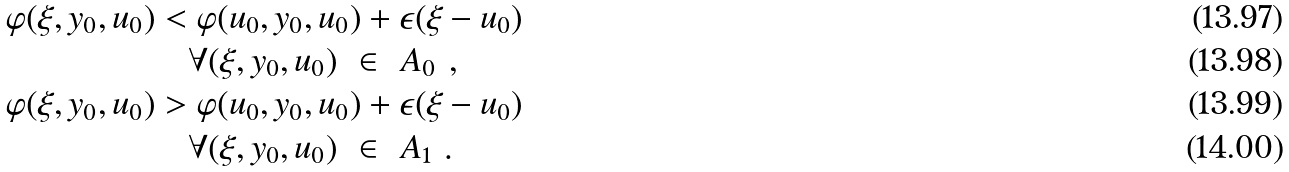<formula> <loc_0><loc_0><loc_500><loc_500>\varphi ( \xi , y _ { 0 } , u _ { 0 } ) & < \varphi ( u _ { 0 } , y _ { 0 } , u _ { 0 } ) + \epsilon ( \xi - u _ { 0 } ) \ \\ & \quad \forall ( \xi , y _ { 0 } , u _ { 0 } ) \ \in \ A _ { 0 } \ , \\ \varphi ( \xi , y _ { 0 } , u _ { 0 } ) & > \varphi ( u _ { 0 } , y _ { 0 } , u _ { 0 } ) + \epsilon ( \xi - u _ { 0 } ) \ \\ & \quad \forall ( \xi , y _ { 0 } , u _ { 0 } ) \ \in \ A _ { 1 } \ .</formula> 